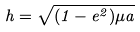<formula> <loc_0><loc_0><loc_500><loc_500>h = \sqrt { ( 1 - e ^ { 2 } ) \mu a }</formula> 